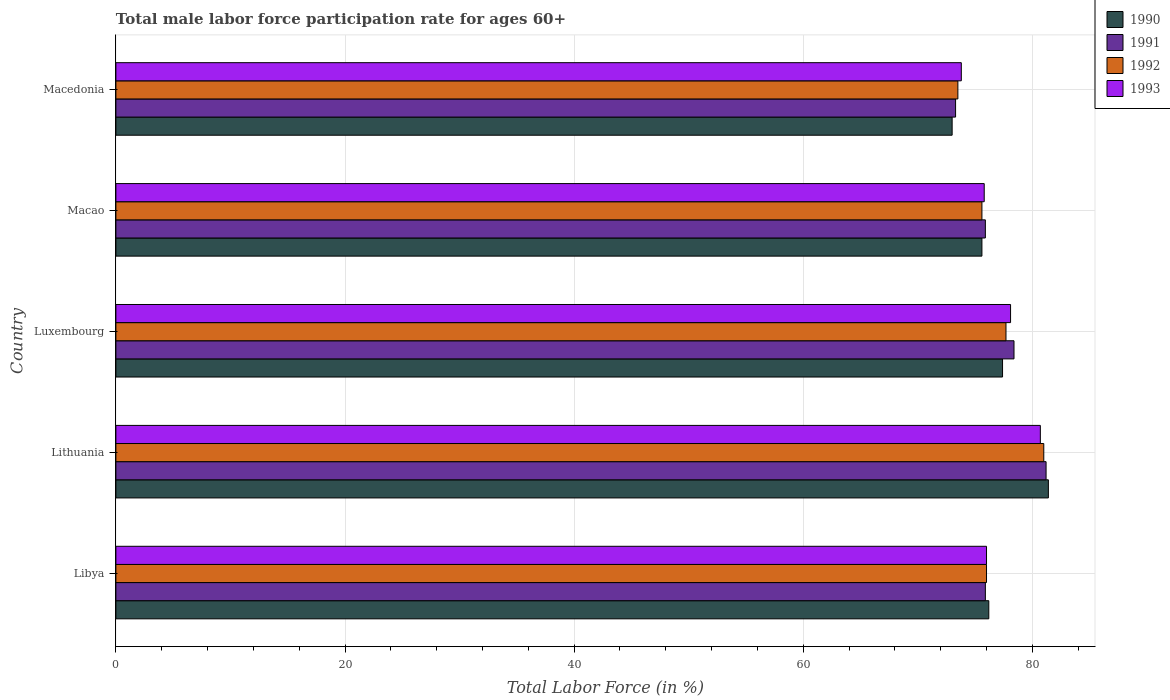How many different coloured bars are there?
Offer a terse response. 4. Are the number of bars per tick equal to the number of legend labels?
Keep it short and to the point. Yes. Are the number of bars on each tick of the Y-axis equal?
Offer a terse response. Yes. How many bars are there on the 1st tick from the top?
Your answer should be very brief. 4. How many bars are there on the 3rd tick from the bottom?
Keep it short and to the point. 4. What is the label of the 4th group of bars from the top?
Keep it short and to the point. Lithuania. What is the male labor force participation rate in 1992 in Macedonia?
Your response must be concise. 73.5. Across all countries, what is the maximum male labor force participation rate in 1990?
Ensure brevity in your answer.  81.4. Across all countries, what is the minimum male labor force participation rate in 1992?
Keep it short and to the point. 73.5. In which country was the male labor force participation rate in 1992 maximum?
Your answer should be compact. Lithuania. In which country was the male labor force participation rate in 1992 minimum?
Keep it short and to the point. Macedonia. What is the total male labor force participation rate in 1990 in the graph?
Give a very brief answer. 383.6. What is the difference between the male labor force participation rate in 1992 in Lithuania and that in Luxembourg?
Keep it short and to the point. 3.3. What is the difference between the male labor force participation rate in 1992 in Macedonia and the male labor force participation rate in 1993 in Lithuania?
Give a very brief answer. -7.2. What is the average male labor force participation rate in 1993 per country?
Your answer should be compact. 76.88. What is the difference between the male labor force participation rate in 1993 and male labor force participation rate in 1991 in Luxembourg?
Your answer should be compact. -0.3. In how many countries, is the male labor force participation rate in 1991 greater than 76 %?
Make the answer very short. 2. What is the ratio of the male labor force participation rate in 1990 in Luxembourg to that in Macao?
Provide a short and direct response. 1.02. Is the male labor force participation rate in 1991 in Luxembourg less than that in Macao?
Give a very brief answer. No. What is the difference between the highest and the lowest male labor force participation rate in 1990?
Provide a short and direct response. 8.4. In how many countries, is the male labor force participation rate in 1992 greater than the average male labor force participation rate in 1992 taken over all countries?
Give a very brief answer. 2. Is the sum of the male labor force participation rate in 1992 in Luxembourg and Macedonia greater than the maximum male labor force participation rate in 1993 across all countries?
Your response must be concise. Yes. Is it the case that in every country, the sum of the male labor force participation rate in 1990 and male labor force participation rate in 1991 is greater than the sum of male labor force participation rate in 1993 and male labor force participation rate in 1992?
Give a very brief answer. No. What does the 1st bar from the bottom in Libya represents?
Your response must be concise. 1990. How many bars are there?
Your answer should be very brief. 20. Are all the bars in the graph horizontal?
Provide a short and direct response. Yes. How many countries are there in the graph?
Provide a short and direct response. 5. What is the difference between two consecutive major ticks on the X-axis?
Your answer should be compact. 20. Are the values on the major ticks of X-axis written in scientific E-notation?
Ensure brevity in your answer.  No. Does the graph contain grids?
Offer a very short reply. Yes. How are the legend labels stacked?
Offer a very short reply. Vertical. What is the title of the graph?
Offer a terse response. Total male labor force participation rate for ages 60+. Does "1963" appear as one of the legend labels in the graph?
Offer a terse response. No. What is the label or title of the X-axis?
Keep it short and to the point. Total Labor Force (in %). What is the Total Labor Force (in %) of 1990 in Libya?
Provide a short and direct response. 76.2. What is the Total Labor Force (in %) in 1991 in Libya?
Your response must be concise. 75.9. What is the Total Labor Force (in %) in 1992 in Libya?
Provide a short and direct response. 76. What is the Total Labor Force (in %) in 1990 in Lithuania?
Ensure brevity in your answer.  81.4. What is the Total Labor Force (in %) in 1991 in Lithuania?
Make the answer very short. 81.2. What is the Total Labor Force (in %) of 1992 in Lithuania?
Ensure brevity in your answer.  81. What is the Total Labor Force (in %) in 1993 in Lithuania?
Make the answer very short. 80.7. What is the Total Labor Force (in %) in 1990 in Luxembourg?
Provide a short and direct response. 77.4. What is the Total Labor Force (in %) in 1991 in Luxembourg?
Provide a short and direct response. 78.4. What is the Total Labor Force (in %) of 1992 in Luxembourg?
Make the answer very short. 77.7. What is the Total Labor Force (in %) of 1993 in Luxembourg?
Ensure brevity in your answer.  78.1. What is the Total Labor Force (in %) of 1990 in Macao?
Your answer should be compact. 75.6. What is the Total Labor Force (in %) in 1991 in Macao?
Offer a terse response. 75.9. What is the Total Labor Force (in %) in 1992 in Macao?
Make the answer very short. 75.6. What is the Total Labor Force (in %) in 1993 in Macao?
Offer a terse response. 75.8. What is the Total Labor Force (in %) in 1991 in Macedonia?
Your answer should be very brief. 73.3. What is the Total Labor Force (in %) in 1992 in Macedonia?
Give a very brief answer. 73.5. What is the Total Labor Force (in %) of 1993 in Macedonia?
Provide a succinct answer. 73.8. Across all countries, what is the maximum Total Labor Force (in %) in 1990?
Your response must be concise. 81.4. Across all countries, what is the maximum Total Labor Force (in %) in 1991?
Give a very brief answer. 81.2. Across all countries, what is the maximum Total Labor Force (in %) of 1993?
Your answer should be compact. 80.7. Across all countries, what is the minimum Total Labor Force (in %) of 1990?
Keep it short and to the point. 73. Across all countries, what is the minimum Total Labor Force (in %) of 1991?
Provide a short and direct response. 73.3. Across all countries, what is the minimum Total Labor Force (in %) of 1992?
Provide a succinct answer. 73.5. Across all countries, what is the minimum Total Labor Force (in %) in 1993?
Your answer should be very brief. 73.8. What is the total Total Labor Force (in %) of 1990 in the graph?
Offer a very short reply. 383.6. What is the total Total Labor Force (in %) of 1991 in the graph?
Offer a terse response. 384.7. What is the total Total Labor Force (in %) in 1992 in the graph?
Ensure brevity in your answer.  383.8. What is the total Total Labor Force (in %) in 1993 in the graph?
Provide a succinct answer. 384.4. What is the difference between the Total Labor Force (in %) of 1990 in Libya and that in Lithuania?
Give a very brief answer. -5.2. What is the difference between the Total Labor Force (in %) of 1992 in Libya and that in Lithuania?
Provide a succinct answer. -5. What is the difference between the Total Labor Force (in %) in 1990 in Libya and that in Luxembourg?
Keep it short and to the point. -1.2. What is the difference between the Total Labor Force (in %) in 1992 in Libya and that in Luxembourg?
Make the answer very short. -1.7. What is the difference between the Total Labor Force (in %) in 1991 in Libya and that in Macao?
Make the answer very short. 0. What is the difference between the Total Labor Force (in %) in 1993 in Libya and that in Macao?
Make the answer very short. 0.2. What is the difference between the Total Labor Force (in %) of 1990 in Libya and that in Macedonia?
Your answer should be compact. 3.2. What is the difference between the Total Labor Force (in %) of 1992 in Libya and that in Macedonia?
Provide a succinct answer. 2.5. What is the difference between the Total Labor Force (in %) of 1991 in Lithuania and that in Macao?
Provide a succinct answer. 5.3. What is the difference between the Total Labor Force (in %) in 1993 in Lithuania and that in Macao?
Offer a very short reply. 4.9. What is the difference between the Total Labor Force (in %) in 1990 in Lithuania and that in Macedonia?
Your response must be concise. 8.4. What is the difference between the Total Labor Force (in %) of 1991 in Lithuania and that in Macedonia?
Your answer should be compact. 7.9. What is the difference between the Total Labor Force (in %) of 1992 in Lithuania and that in Macedonia?
Your answer should be compact. 7.5. What is the difference between the Total Labor Force (in %) in 1990 in Luxembourg and that in Macao?
Your answer should be very brief. 1.8. What is the difference between the Total Labor Force (in %) of 1991 in Luxembourg and that in Macao?
Provide a short and direct response. 2.5. What is the difference between the Total Labor Force (in %) in 1993 in Luxembourg and that in Macao?
Keep it short and to the point. 2.3. What is the difference between the Total Labor Force (in %) in 1992 in Luxembourg and that in Macedonia?
Provide a succinct answer. 4.2. What is the difference between the Total Labor Force (in %) in 1993 in Luxembourg and that in Macedonia?
Give a very brief answer. 4.3. What is the difference between the Total Labor Force (in %) in 1991 in Macao and that in Macedonia?
Your answer should be compact. 2.6. What is the difference between the Total Labor Force (in %) in 1992 in Macao and that in Macedonia?
Offer a terse response. 2.1. What is the difference between the Total Labor Force (in %) of 1990 in Libya and the Total Labor Force (in %) of 1992 in Lithuania?
Make the answer very short. -4.8. What is the difference between the Total Labor Force (in %) of 1990 in Libya and the Total Labor Force (in %) of 1993 in Lithuania?
Provide a succinct answer. -4.5. What is the difference between the Total Labor Force (in %) of 1991 in Libya and the Total Labor Force (in %) of 1992 in Lithuania?
Your answer should be very brief. -5.1. What is the difference between the Total Labor Force (in %) of 1991 in Libya and the Total Labor Force (in %) of 1993 in Lithuania?
Provide a succinct answer. -4.8. What is the difference between the Total Labor Force (in %) of 1990 in Libya and the Total Labor Force (in %) of 1991 in Luxembourg?
Make the answer very short. -2.2. What is the difference between the Total Labor Force (in %) of 1991 in Libya and the Total Labor Force (in %) of 1992 in Luxembourg?
Provide a short and direct response. -1.8. What is the difference between the Total Labor Force (in %) in 1991 in Libya and the Total Labor Force (in %) in 1993 in Luxembourg?
Offer a terse response. -2.2. What is the difference between the Total Labor Force (in %) of 1990 in Libya and the Total Labor Force (in %) of 1991 in Macao?
Your answer should be compact. 0.3. What is the difference between the Total Labor Force (in %) in 1990 in Libya and the Total Labor Force (in %) in 1993 in Macao?
Your answer should be compact. 0.4. What is the difference between the Total Labor Force (in %) in 1991 in Libya and the Total Labor Force (in %) in 1993 in Macao?
Give a very brief answer. 0.1. What is the difference between the Total Labor Force (in %) of 1990 in Libya and the Total Labor Force (in %) of 1991 in Macedonia?
Keep it short and to the point. 2.9. What is the difference between the Total Labor Force (in %) in 1990 in Libya and the Total Labor Force (in %) in 1992 in Macedonia?
Give a very brief answer. 2.7. What is the difference between the Total Labor Force (in %) of 1992 in Libya and the Total Labor Force (in %) of 1993 in Macedonia?
Provide a succinct answer. 2.2. What is the difference between the Total Labor Force (in %) in 1990 in Lithuania and the Total Labor Force (in %) in 1991 in Luxembourg?
Provide a succinct answer. 3. What is the difference between the Total Labor Force (in %) in 1990 in Lithuania and the Total Labor Force (in %) in 1992 in Luxembourg?
Make the answer very short. 3.7. What is the difference between the Total Labor Force (in %) of 1992 in Lithuania and the Total Labor Force (in %) of 1993 in Luxembourg?
Make the answer very short. 2.9. What is the difference between the Total Labor Force (in %) in 1990 in Lithuania and the Total Labor Force (in %) in 1993 in Macao?
Your answer should be compact. 5.6. What is the difference between the Total Labor Force (in %) of 1991 in Lithuania and the Total Labor Force (in %) of 1992 in Macao?
Provide a short and direct response. 5.6. What is the difference between the Total Labor Force (in %) of 1990 in Lithuania and the Total Labor Force (in %) of 1992 in Macedonia?
Provide a short and direct response. 7.9. What is the difference between the Total Labor Force (in %) in 1990 in Lithuania and the Total Labor Force (in %) in 1993 in Macedonia?
Your answer should be very brief. 7.6. What is the difference between the Total Labor Force (in %) in 1992 in Lithuania and the Total Labor Force (in %) in 1993 in Macedonia?
Ensure brevity in your answer.  7.2. What is the difference between the Total Labor Force (in %) in 1991 in Luxembourg and the Total Labor Force (in %) in 1992 in Macao?
Provide a succinct answer. 2.8. What is the difference between the Total Labor Force (in %) of 1991 in Luxembourg and the Total Labor Force (in %) of 1993 in Macao?
Offer a terse response. 2.6. What is the difference between the Total Labor Force (in %) of 1992 in Luxembourg and the Total Labor Force (in %) of 1993 in Macao?
Your answer should be very brief. 1.9. What is the difference between the Total Labor Force (in %) of 1990 in Luxembourg and the Total Labor Force (in %) of 1992 in Macedonia?
Your answer should be very brief. 3.9. What is the difference between the Total Labor Force (in %) in 1991 in Luxembourg and the Total Labor Force (in %) in 1992 in Macedonia?
Offer a terse response. 4.9. What is the difference between the Total Labor Force (in %) of 1990 in Macao and the Total Labor Force (in %) of 1992 in Macedonia?
Offer a terse response. 2.1. What is the difference between the Total Labor Force (in %) in 1990 in Macao and the Total Labor Force (in %) in 1993 in Macedonia?
Provide a succinct answer. 1.8. What is the difference between the Total Labor Force (in %) of 1992 in Macao and the Total Labor Force (in %) of 1993 in Macedonia?
Your answer should be very brief. 1.8. What is the average Total Labor Force (in %) of 1990 per country?
Provide a short and direct response. 76.72. What is the average Total Labor Force (in %) in 1991 per country?
Offer a very short reply. 76.94. What is the average Total Labor Force (in %) of 1992 per country?
Ensure brevity in your answer.  76.76. What is the average Total Labor Force (in %) in 1993 per country?
Make the answer very short. 76.88. What is the difference between the Total Labor Force (in %) of 1990 and Total Labor Force (in %) of 1991 in Libya?
Your answer should be very brief. 0.3. What is the difference between the Total Labor Force (in %) of 1990 and Total Labor Force (in %) of 1993 in Libya?
Offer a very short reply. 0.2. What is the difference between the Total Labor Force (in %) of 1991 and Total Labor Force (in %) of 1993 in Libya?
Provide a short and direct response. -0.1. What is the difference between the Total Labor Force (in %) of 1990 and Total Labor Force (in %) of 1991 in Lithuania?
Offer a very short reply. 0.2. What is the difference between the Total Labor Force (in %) of 1990 and Total Labor Force (in %) of 1992 in Lithuania?
Keep it short and to the point. 0.4. What is the difference between the Total Labor Force (in %) in 1990 and Total Labor Force (in %) in 1993 in Lithuania?
Your answer should be compact. 0.7. What is the difference between the Total Labor Force (in %) in 1991 and Total Labor Force (in %) in 1992 in Lithuania?
Your answer should be compact. 0.2. What is the difference between the Total Labor Force (in %) in 1991 and Total Labor Force (in %) in 1993 in Lithuania?
Keep it short and to the point. 0.5. What is the difference between the Total Labor Force (in %) of 1990 and Total Labor Force (in %) of 1991 in Luxembourg?
Your answer should be very brief. -1. What is the difference between the Total Labor Force (in %) of 1990 and Total Labor Force (in %) of 1992 in Luxembourg?
Ensure brevity in your answer.  -0.3. What is the difference between the Total Labor Force (in %) in 1990 and Total Labor Force (in %) in 1993 in Luxembourg?
Your answer should be very brief. -0.7. What is the difference between the Total Labor Force (in %) of 1990 and Total Labor Force (in %) of 1991 in Macao?
Your answer should be very brief. -0.3. What is the difference between the Total Labor Force (in %) in 1990 and Total Labor Force (in %) in 1992 in Macao?
Provide a short and direct response. 0. What is the difference between the Total Labor Force (in %) in 1990 and Total Labor Force (in %) in 1993 in Macao?
Your response must be concise. -0.2. What is the difference between the Total Labor Force (in %) of 1991 and Total Labor Force (in %) of 1993 in Macao?
Provide a short and direct response. 0.1. What is the difference between the Total Labor Force (in %) in 1992 and Total Labor Force (in %) in 1993 in Macao?
Provide a succinct answer. -0.2. What is the difference between the Total Labor Force (in %) in 1990 and Total Labor Force (in %) in 1992 in Macedonia?
Your answer should be very brief. -0.5. What is the difference between the Total Labor Force (in %) of 1991 and Total Labor Force (in %) of 1993 in Macedonia?
Provide a succinct answer. -0.5. What is the ratio of the Total Labor Force (in %) of 1990 in Libya to that in Lithuania?
Your answer should be compact. 0.94. What is the ratio of the Total Labor Force (in %) of 1991 in Libya to that in Lithuania?
Offer a terse response. 0.93. What is the ratio of the Total Labor Force (in %) in 1992 in Libya to that in Lithuania?
Give a very brief answer. 0.94. What is the ratio of the Total Labor Force (in %) of 1993 in Libya to that in Lithuania?
Make the answer very short. 0.94. What is the ratio of the Total Labor Force (in %) in 1990 in Libya to that in Luxembourg?
Ensure brevity in your answer.  0.98. What is the ratio of the Total Labor Force (in %) in 1991 in Libya to that in Luxembourg?
Keep it short and to the point. 0.97. What is the ratio of the Total Labor Force (in %) of 1992 in Libya to that in Luxembourg?
Keep it short and to the point. 0.98. What is the ratio of the Total Labor Force (in %) in 1993 in Libya to that in Luxembourg?
Offer a terse response. 0.97. What is the ratio of the Total Labor Force (in %) in 1990 in Libya to that in Macao?
Ensure brevity in your answer.  1.01. What is the ratio of the Total Labor Force (in %) of 1991 in Libya to that in Macao?
Ensure brevity in your answer.  1. What is the ratio of the Total Labor Force (in %) in 1992 in Libya to that in Macao?
Provide a succinct answer. 1.01. What is the ratio of the Total Labor Force (in %) in 1993 in Libya to that in Macao?
Your response must be concise. 1. What is the ratio of the Total Labor Force (in %) of 1990 in Libya to that in Macedonia?
Your answer should be compact. 1.04. What is the ratio of the Total Labor Force (in %) in 1991 in Libya to that in Macedonia?
Keep it short and to the point. 1.04. What is the ratio of the Total Labor Force (in %) of 1992 in Libya to that in Macedonia?
Provide a short and direct response. 1.03. What is the ratio of the Total Labor Force (in %) in 1993 in Libya to that in Macedonia?
Make the answer very short. 1.03. What is the ratio of the Total Labor Force (in %) in 1990 in Lithuania to that in Luxembourg?
Keep it short and to the point. 1.05. What is the ratio of the Total Labor Force (in %) of 1991 in Lithuania to that in Luxembourg?
Make the answer very short. 1.04. What is the ratio of the Total Labor Force (in %) of 1992 in Lithuania to that in Luxembourg?
Your answer should be very brief. 1.04. What is the ratio of the Total Labor Force (in %) of 1993 in Lithuania to that in Luxembourg?
Your answer should be compact. 1.03. What is the ratio of the Total Labor Force (in %) of 1990 in Lithuania to that in Macao?
Make the answer very short. 1.08. What is the ratio of the Total Labor Force (in %) in 1991 in Lithuania to that in Macao?
Offer a very short reply. 1.07. What is the ratio of the Total Labor Force (in %) of 1992 in Lithuania to that in Macao?
Provide a short and direct response. 1.07. What is the ratio of the Total Labor Force (in %) of 1993 in Lithuania to that in Macao?
Make the answer very short. 1.06. What is the ratio of the Total Labor Force (in %) in 1990 in Lithuania to that in Macedonia?
Make the answer very short. 1.12. What is the ratio of the Total Labor Force (in %) in 1991 in Lithuania to that in Macedonia?
Your answer should be very brief. 1.11. What is the ratio of the Total Labor Force (in %) in 1992 in Lithuania to that in Macedonia?
Offer a terse response. 1.1. What is the ratio of the Total Labor Force (in %) in 1993 in Lithuania to that in Macedonia?
Offer a terse response. 1.09. What is the ratio of the Total Labor Force (in %) in 1990 in Luxembourg to that in Macao?
Offer a very short reply. 1.02. What is the ratio of the Total Labor Force (in %) in 1991 in Luxembourg to that in Macao?
Keep it short and to the point. 1.03. What is the ratio of the Total Labor Force (in %) of 1992 in Luxembourg to that in Macao?
Offer a very short reply. 1.03. What is the ratio of the Total Labor Force (in %) of 1993 in Luxembourg to that in Macao?
Ensure brevity in your answer.  1.03. What is the ratio of the Total Labor Force (in %) of 1990 in Luxembourg to that in Macedonia?
Ensure brevity in your answer.  1.06. What is the ratio of the Total Labor Force (in %) in 1991 in Luxembourg to that in Macedonia?
Make the answer very short. 1.07. What is the ratio of the Total Labor Force (in %) of 1992 in Luxembourg to that in Macedonia?
Make the answer very short. 1.06. What is the ratio of the Total Labor Force (in %) of 1993 in Luxembourg to that in Macedonia?
Your answer should be compact. 1.06. What is the ratio of the Total Labor Force (in %) in 1990 in Macao to that in Macedonia?
Provide a succinct answer. 1.04. What is the ratio of the Total Labor Force (in %) of 1991 in Macao to that in Macedonia?
Keep it short and to the point. 1.04. What is the ratio of the Total Labor Force (in %) of 1992 in Macao to that in Macedonia?
Your answer should be very brief. 1.03. What is the ratio of the Total Labor Force (in %) in 1993 in Macao to that in Macedonia?
Your response must be concise. 1.03. What is the difference between the highest and the second highest Total Labor Force (in %) of 1990?
Ensure brevity in your answer.  4. What is the difference between the highest and the second highest Total Labor Force (in %) in 1992?
Provide a succinct answer. 3.3. What is the difference between the highest and the lowest Total Labor Force (in %) in 1991?
Give a very brief answer. 7.9. What is the difference between the highest and the lowest Total Labor Force (in %) in 1993?
Your response must be concise. 6.9. 